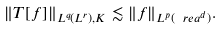Convert formula to latex. <formula><loc_0><loc_0><loc_500><loc_500>\| T [ f ] \| _ { L ^ { q } ( L ^ { r } ) , K } \lesssim \| f \| _ { L ^ { p } ( \ r e a ^ { d } ) } .</formula> 